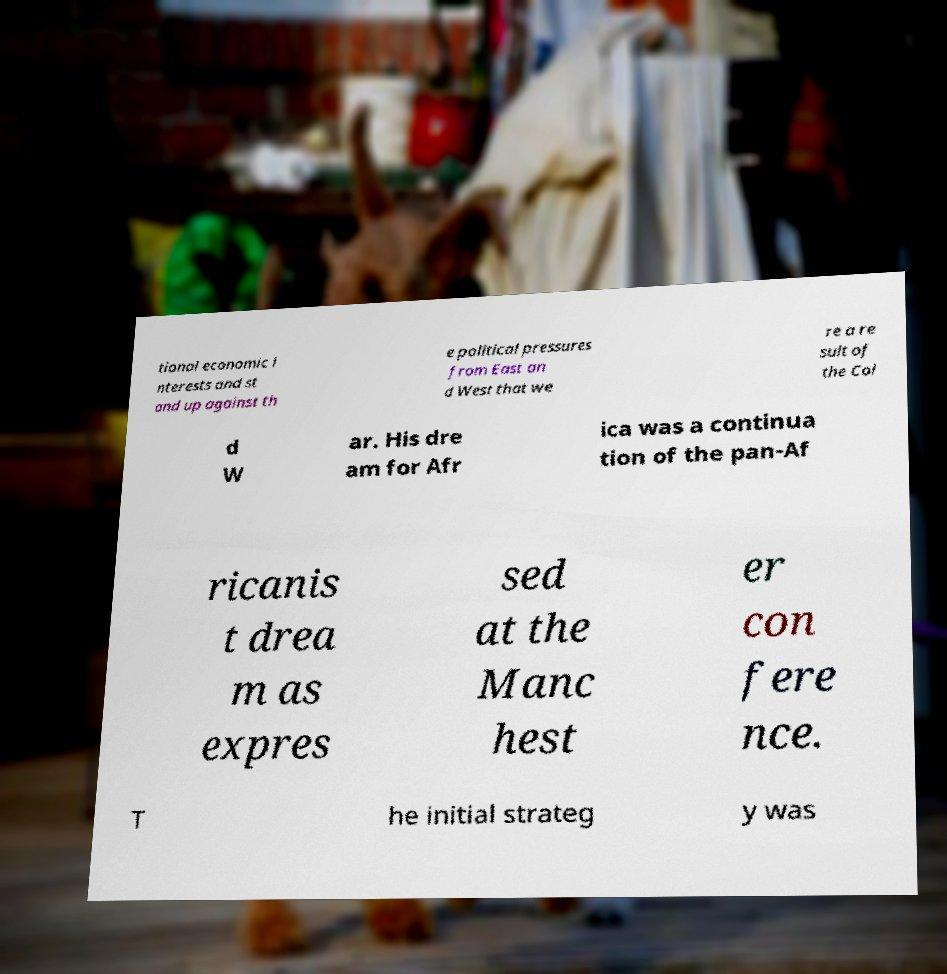Please identify and transcribe the text found in this image. tional economic i nterests and st and up against th e political pressures from East an d West that we re a re sult of the Col d W ar. His dre am for Afr ica was a continua tion of the pan-Af ricanis t drea m as expres sed at the Manc hest er con fere nce. T he initial strateg y was 